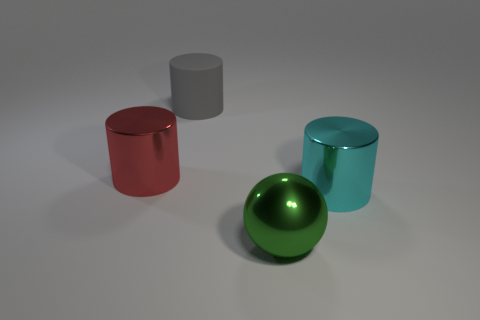What material is the large gray object that is the same shape as the large red thing?
Make the answer very short. Rubber. There is a object that is in front of the large cyan metal thing; is its size the same as the cylinder in front of the big red shiny cylinder?
Give a very brief answer. Yes. The large object that is both in front of the gray rubber thing and on the left side of the big green ball has what shape?
Provide a succinct answer. Cylinder. Are there any tiny green cubes made of the same material as the red object?
Provide a succinct answer. No. Do the big object that is in front of the large cyan metal object and the cylinder left of the gray matte object have the same material?
Keep it short and to the point. Yes. Are there more cylinders than yellow metallic blocks?
Provide a succinct answer. Yes. There is a cylinder that is behind the shiny cylinder behind the big cylinder in front of the red metallic cylinder; what color is it?
Provide a short and direct response. Gray. Is the color of the big object that is right of the big green metallic ball the same as the shiny object that is on the left side of the rubber cylinder?
Make the answer very short. No. There is a metallic thing that is on the left side of the big rubber object; how many big cyan shiny cylinders are left of it?
Give a very brief answer. 0. Are any big yellow matte things visible?
Provide a succinct answer. No. 